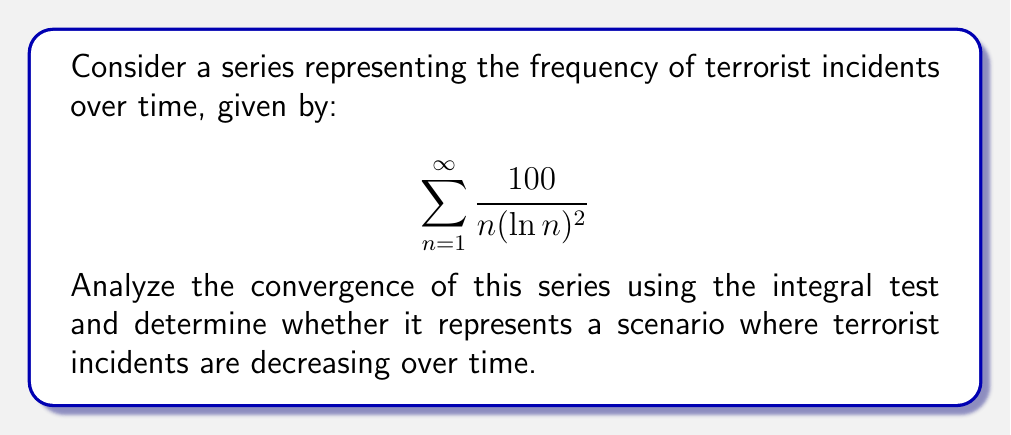Can you solve this math problem? To analyze the convergence of this series, we'll use the integral test. Let's break it down step-by-step:

1) First, we define the function $f(x) = \frac{100}{x(\ln x)^2}$ for $x \geq 2$.

2) To apply the integral test, we need to check if $f(x)$ is continuous, positive, and decreasing for $x \geq 2$. 
   - $f(x)$ is continuous for $x \geq 2$
   - $f(x)$ is positive for $x \geq 2$
   - To check if it's decreasing, we can take the derivative:
     $$f'(x) = -\frac{100}{x^2(\ln x)^2} - \frac{200}{x^2(\ln x)^3}$$
     This is negative for $x \geq 2$, so $f(x)$ is decreasing.

3) Now we can apply the integral test. We need to evaluate:
   $$\int_2^{\infty} \frac{100}{x(\ln x)^2} dx$$

4) Let $u = \ln x$, then $du = \frac{1}{x}dx$, so:
   $$\int_2^{\infty} \frac{100}{x(\ln x)^2} dx = \int_{\ln 2}^{\infty} \frac{100}{u^2} du$$

5) Evaluating this integral:
   $$\left[-\frac{100}{u}\right]_{\ln 2}^{\infty} = 0 - \left(-\frac{100}{\ln 2}\right) = \frac{100}{\ln 2}$$

6) Since this integral converges to a finite value, by the integral test, the original series also converges.

Regarding the interpretation for terrorist incidents:
The convergence of the series suggests that the sum of all incidents over time is finite. This implies that the frequency of incidents is decreasing over time, as the terms of the series become smaller for larger $n$ (representing later time periods).
Answer: The series $\sum_{n=1}^{\infty} \frac{100}{n(\ln n)^2}$ converges. This represents a scenario where the frequency of terrorist incidents is decreasing over time, with the total number of incidents over an infinite time period remaining finite. 